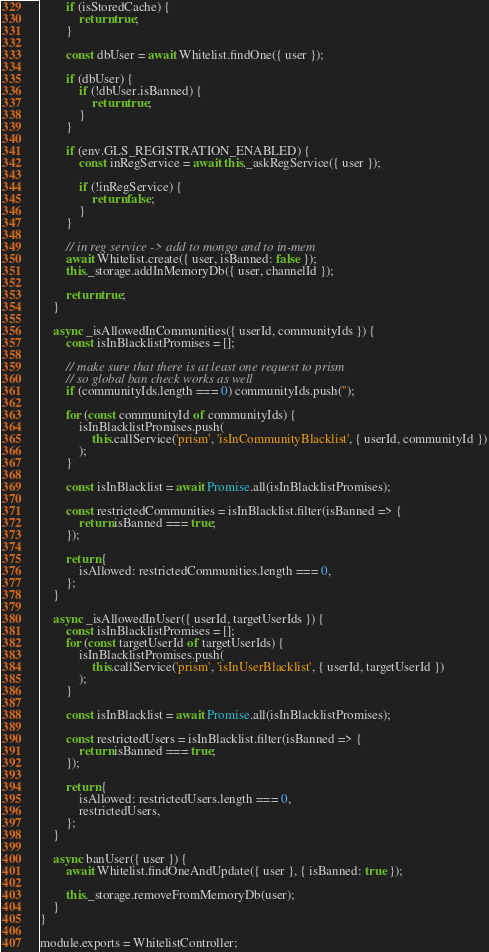<code> <loc_0><loc_0><loc_500><loc_500><_JavaScript_>        if (isStoredCache) {
            return true;
        }

        const dbUser = await Whitelist.findOne({ user });

        if (dbUser) {
            if (!dbUser.isBanned) {
                return true;
            }
        }

        if (env.GLS_REGISTRATION_ENABLED) {
            const inRegService = await this._askRegService({ user });

            if (!inRegService) {
                return false;
            }
        }

        // in reg service -> add to mongo and to in-mem
        await Whitelist.create({ user, isBanned: false });
        this._storage.addInMemoryDb({ user, channelId });

        return true;
    }

    async _isAllowedInCommunities({ userId, communityIds }) {
        const isInBlacklistPromises = [];

        // make sure that there is at least one request to prism
        // so global ban check works as well
        if (communityIds.length === 0) communityIds.push('');

        for (const communityId of communityIds) {
            isInBlacklistPromises.push(
                this.callService('prism', 'isInCommunityBlacklist', { userId, communityId })
            );
        }

        const isInBlacklist = await Promise.all(isInBlacklistPromises);

        const restrictedCommunities = isInBlacklist.filter(isBanned => {
            return isBanned === true;
        });

        return {
            isAllowed: restrictedCommunities.length === 0,
        };
    }

    async _isAllowedInUser({ userId, targetUserIds }) {
        const isInBlacklistPromises = [];
        for (const targetUserId of targetUserIds) {
            isInBlacklistPromises.push(
                this.callService('prism', 'isInUserBlacklist', { userId, targetUserId })
            );
        }

        const isInBlacklist = await Promise.all(isInBlacklistPromises);

        const restrictedUsers = isInBlacklist.filter(isBanned => {
            return isBanned === true;
        });

        return {
            isAllowed: restrictedUsers.length === 0,
            restrictedUsers,
        };
    }

    async banUser({ user }) {
        await Whitelist.findOneAndUpdate({ user }, { isBanned: true });

        this._storage.removeFromMemoryDb(user);
    }
}

module.exports = WhitelistController;
</code> 